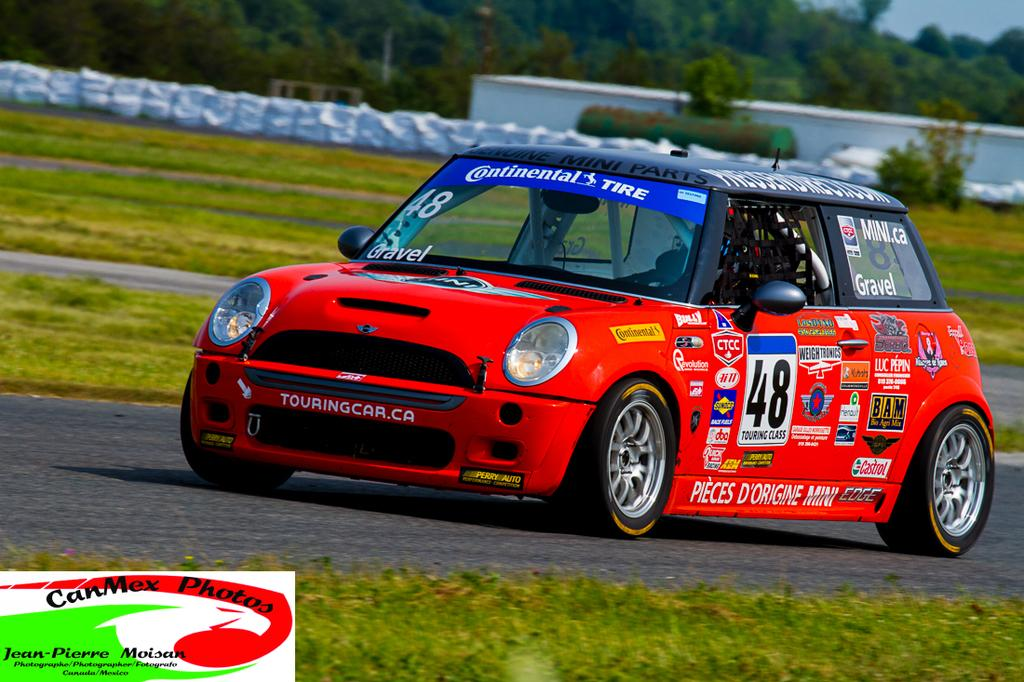What color is the car in the image? The car in the image is red. What is the car doing in the image? The car is moving on the road. What can be seen in the background of the image? There are trees visible in the image. What type of pie is being traded between the trees in the image? There is no pie or trade present in the image; it features a red car moving on the road with trees in the background. What color is the shirt worn by the car in the image? Cars do not wear shirts, so this question cannot be answered based on the information provided. 